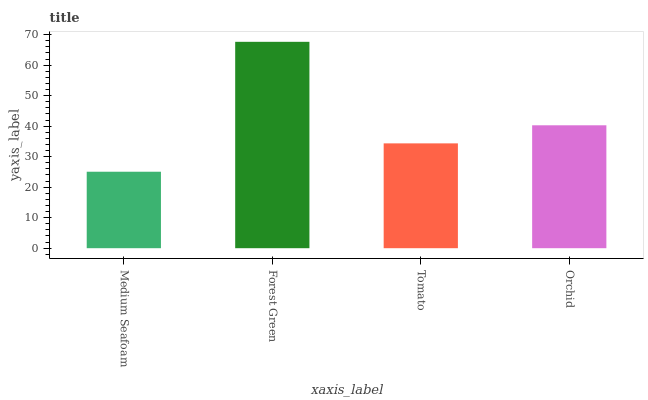Is Medium Seafoam the minimum?
Answer yes or no. Yes. Is Forest Green the maximum?
Answer yes or no. Yes. Is Tomato the minimum?
Answer yes or no. No. Is Tomato the maximum?
Answer yes or no. No. Is Forest Green greater than Tomato?
Answer yes or no. Yes. Is Tomato less than Forest Green?
Answer yes or no. Yes. Is Tomato greater than Forest Green?
Answer yes or no. No. Is Forest Green less than Tomato?
Answer yes or no. No. Is Orchid the high median?
Answer yes or no. Yes. Is Tomato the low median?
Answer yes or no. Yes. Is Tomato the high median?
Answer yes or no. No. Is Orchid the low median?
Answer yes or no. No. 